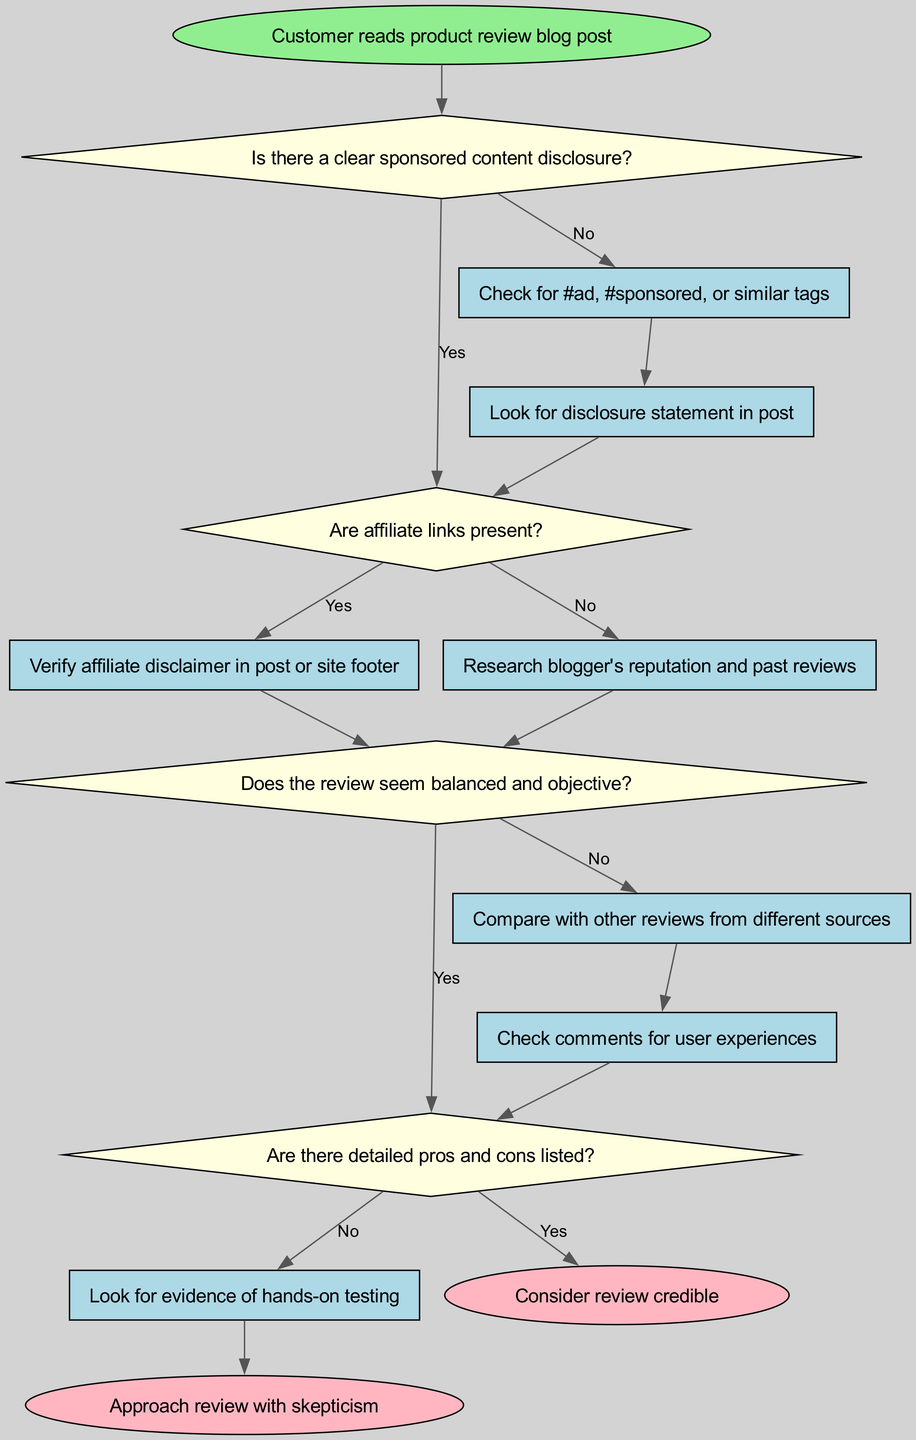What is the first action taken if there is no disclosure? If there is no sponsored content disclosure, the flowchart directs to action 1 where one would check for specific tags like #ad or #sponsored.
Answer: Check for #ad, #sponsored, or similar tags What action follows after verifying affiliate links? After checking for affiliate links, if they are present, one should verify the affiliate disclaimer in the post or site footer according to the flow.
Answer: Verify affiliate disclaimer in post or site footer How many decision nodes are present in the diagram? There are four decision nodes in the diagram: decision1, decision2, decision3, and decision4.
Answer: 4 If the review seems balanced and objective, what is the next step? If the review appears balanced and objective, it leads to decision 4, which checks if detailed pros and cons are listed.
Answer: Check comments for user experiences Under which condition would you consider the review credible? The review would be considered credible if there are detailed pros and cons listed, leading to the end node 1.
Answer: Consider review credible What happens if there are no detailed pros and cons listed? If there are no detailed pros and cons available in the review, this leads to the action of looking for evidence of hands-on testing in the flowchart.
Answer: Look for evidence of hands-on testing What is the outcome if there is no clear sponsored content disclosure? In the absence of a clear sponsored content disclosure, one would approach the review with skepticism, which is indicated by end node 2.
Answer: Approach review with skepticism What should a customer do after checking the comments? After checking the comments for user experiences, it goes back to the decision of whether the review is balanced and objective, which may lead to considering it credible or skeptical.
Answer: Consider review credible or Approach review with skepticism What is the end result if there is a clear sponsored content disclosure and detailed pros and cons are listed? If there is a clear sponsored content disclosure and the review lists detailed pros and cons, the outcome is to consider the review credible.
Answer: Consider review credible 